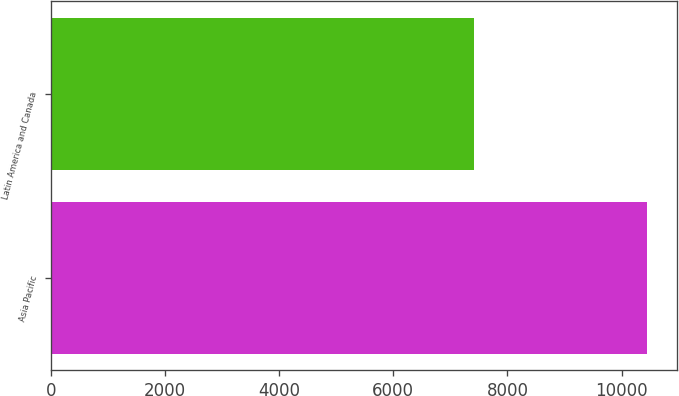<chart> <loc_0><loc_0><loc_500><loc_500><bar_chart><fcel>Asia Pacific<fcel>Latin America and Canada<nl><fcel>10439<fcel>7410<nl></chart> 